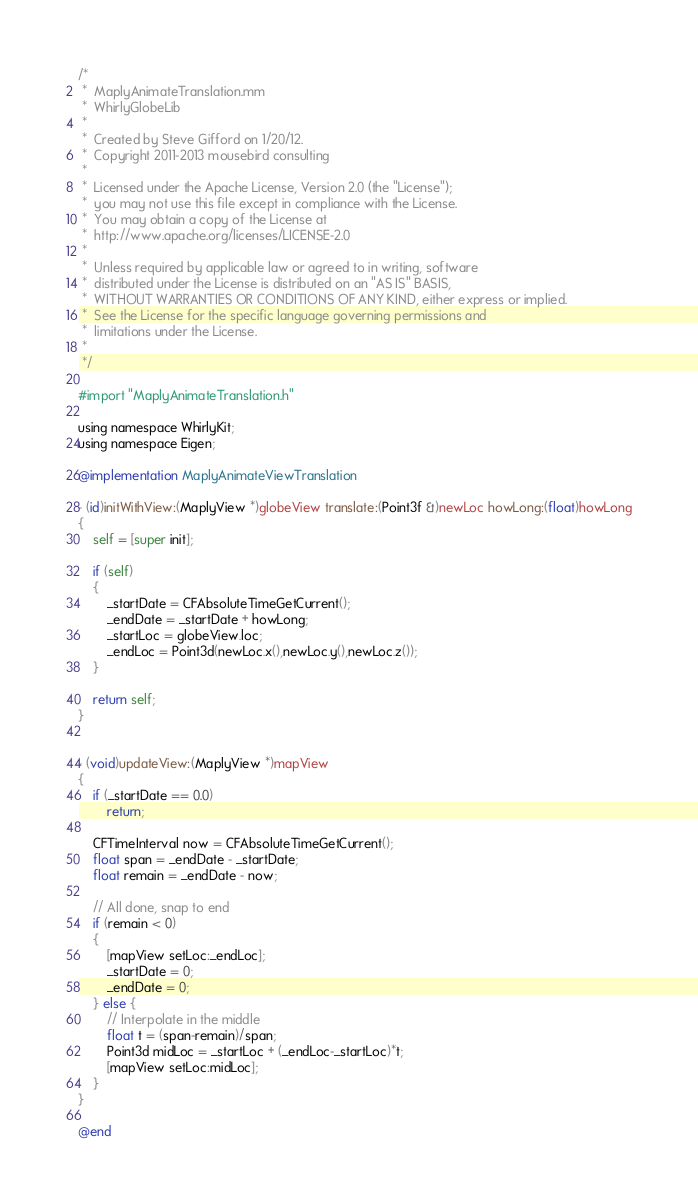<code> <loc_0><loc_0><loc_500><loc_500><_ObjectiveC_>/*
 *  MaplyAnimateTranslation.mm
 *  WhirlyGlobeLib
 *
 *  Created by Steve Gifford on 1/20/12.
 *  Copyright 2011-2013 mousebird consulting
 *
 *  Licensed under the Apache License, Version 2.0 (the "License");
 *  you may not use this file except in compliance with the License.
 *  You may obtain a copy of the License at
 *  http://www.apache.org/licenses/LICENSE-2.0
 *
 *  Unless required by applicable law or agreed to in writing, software
 *  distributed under the License is distributed on an "AS IS" BASIS,
 *  WITHOUT WARRANTIES OR CONDITIONS OF ANY KIND, either express or implied.
 *  See the License for the specific language governing permissions and
 *  limitations under the License.
 *
 */

#import "MaplyAnimateTranslation.h"

using namespace WhirlyKit;
using namespace Eigen;

@implementation MaplyAnimateViewTranslation

- (id)initWithView:(MaplyView *)globeView translate:(Point3f &)newLoc howLong:(float)howLong
{
    self = [super init];
    
    if (self)
    {
        _startDate = CFAbsoluteTimeGetCurrent();
        _endDate = _startDate + howLong;
        _startLoc = globeView.loc;
        _endLoc = Point3d(newLoc.x(),newLoc.y(),newLoc.z());
    }
    
    return self;
}


- (void)updateView:(MaplyView *)mapView
{
    if (_startDate == 0.0)
        return;

    CFTimeInterval now = CFAbsoluteTimeGetCurrent();
    float span = _endDate - _startDate;
    float remain = _endDate - now;
    
    // All done, snap to end
    if (remain < 0)
    {
        [mapView setLoc:_endLoc];
        _startDate = 0;
        _endDate = 0;
    } else {
        // Interpolate in the middle
        float t = (span-remain)/span;
        Point3d midLoc = _startLoc + (_endLoc-_startLoc)*t;
        [mapView setLoc:midLoc];
    }
}

@end
</code> 